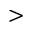<formula> <loc_0><loc_0><loc_500><loc_500>></formula> 